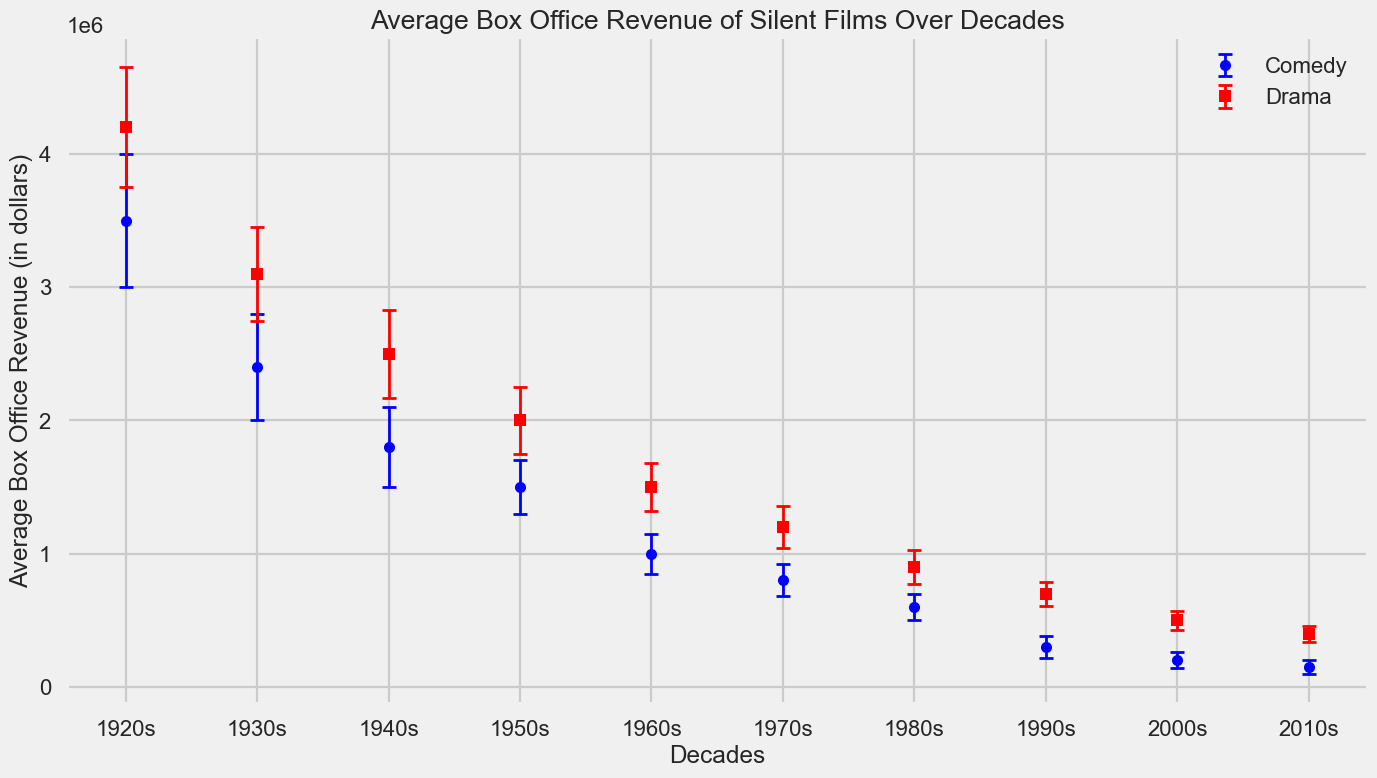Which genre had the higher average box office revenue in the 1920s? By looking at the data points for the 1920s, Comedy has an average box office revenue of $3,500,000 while Drama has $4,200,000. Therefore, Drama had the higher average in the 1920s.
Answer: Drama How did the average box office revenue for Comedy films change from the 1920s to the 1980s? In the 1920s, Comedy films had an average revenue of $3,500,000, and by the 1980s, it decreased to $600,000. To find the change, subtract $600,000 from $3,500,000, which is $2,900,000.
Answer: Decreased by $2,900,000 Which decade shows the biggest difference in average box office revenue between Comedy and Drama genres? Look at the differences in each decade: 
1920s: $700,000 
1930s: $700,000 
1940s: $700,000 
1950s: $500,000 
1960s: $500,000 
1970s: $400,000 
1980s: $300,000 
1990s: $400,000 
2000s: $300,000 
2010s: $250,000. The biggest difference is in the 1920s.
Answer: 1920s Which genre had a consistent decline in box office revenues from the 1920s to the 2010s? By examining each genre's trend across the decades, Comedy consistently declines from $3,500,000 in the 1920s to $150,000 in the 2010s.
Answer: Comedy In what decade did Drama films first fall below $1,000,000 in average box office revenue? Observing the data points for Drama, it first falls below $1,000,000 in the 1980s with an average revenue of $900,000.
Answer: 1980s 